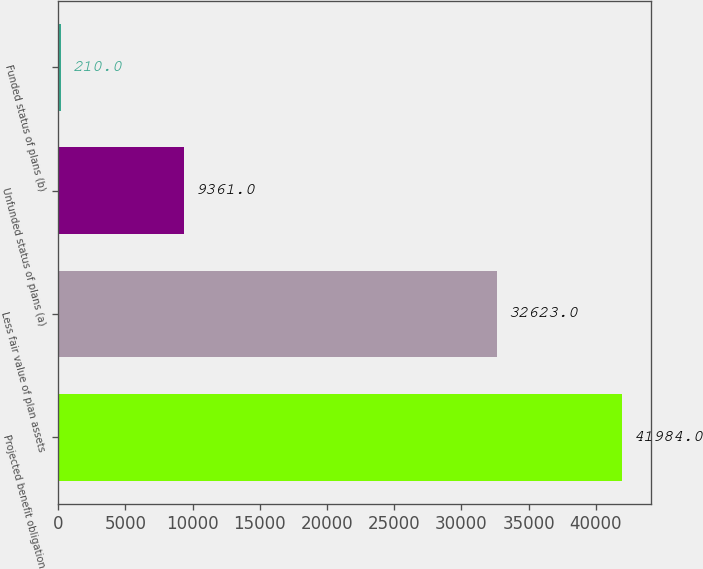<chart> <loc_0><loc_0><loc_500><loc_500><bar_chart><fcel>Projected benefit obligation<fcel>Less fair value of plan assets<fcel>Unfunded status of plans (a)<fcel>Funded status of plans (b)<nl><fcel>41984<fcel>32623<fcel>9361<fcel>210<nl></chart> 